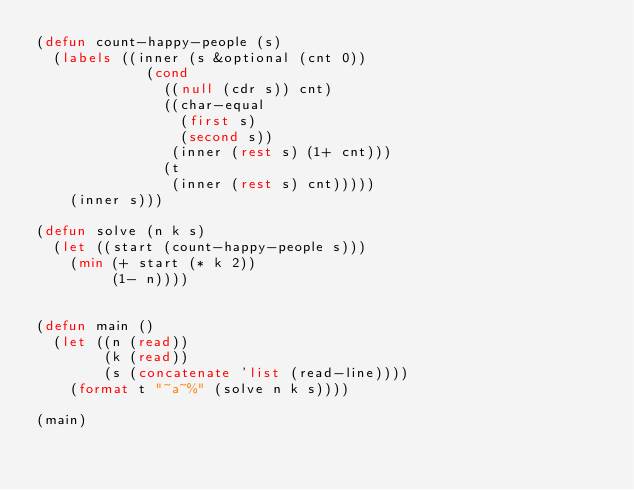<code> <loc_0><loc_0><loc_500><loc_500><_Lisp_>(defun count-happy-people (s)
  (labels ((inner (s &optional (cnt 0))
             (cond
               ((null (cdr s)) cnt)
               ((char-equal
                 (first s)
                 (second s))
                (inner (rest s) (1+ cnt)))
               (t
                (inner (rest s) cnt)))))
    (inner s)))

(defun solve (n k s)
  (let ((start (count-happy-people s)))
    (min (+ start (* k 2))
         (1- n))))


(defun main ()
  (let ((n (read))
        (k (read))
        (s (concatenate 'list (read-line))))
    (format t "~a~%" (solve n k s))))

(main)
</code> 